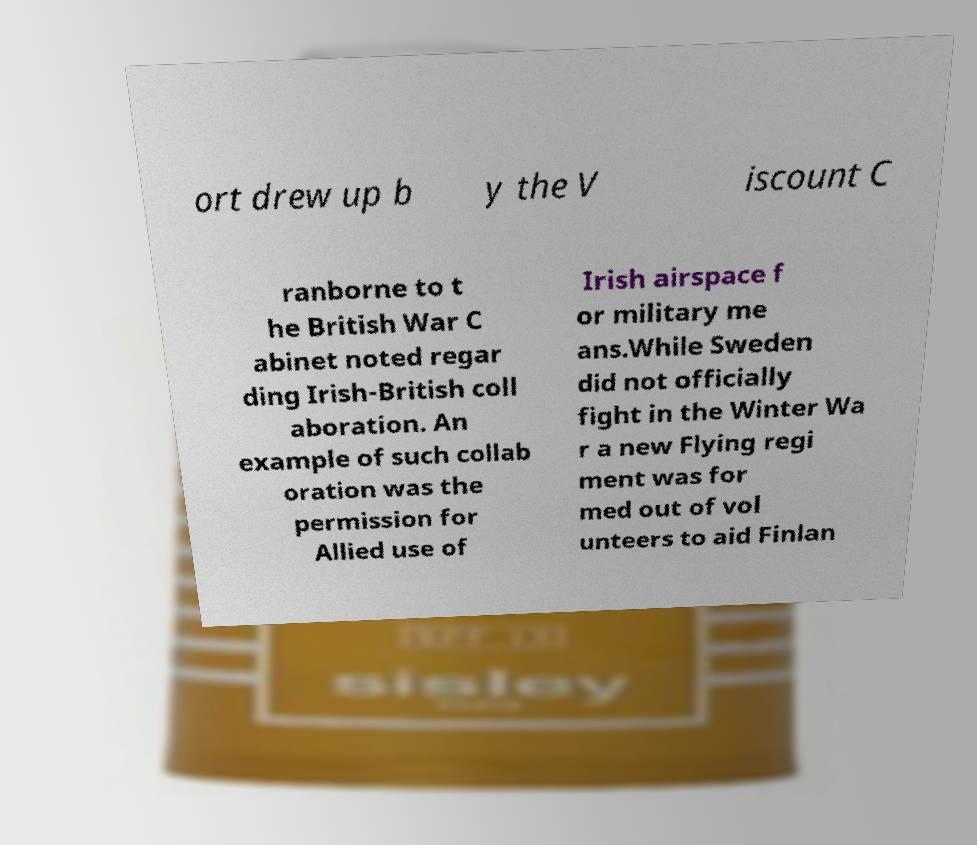Please read and relay the text visible in this image. What does it say? ort drew up b y the V iscount C ranborne to t he British War C abinet noted regar ding Irish-British coll aboration. An example of such collab oration was the permission for Allied use of Irish airspace f or military me ans.While Sweden did not officially fight in the Winter Wa r a new Flying regi ment was for med out of vol unteers to aid Finlan 